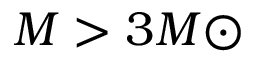Convert formula to latex. <formula><loc_0><loc_0><loc_500><loc_500>M > 3 M { \odot }</formula> 